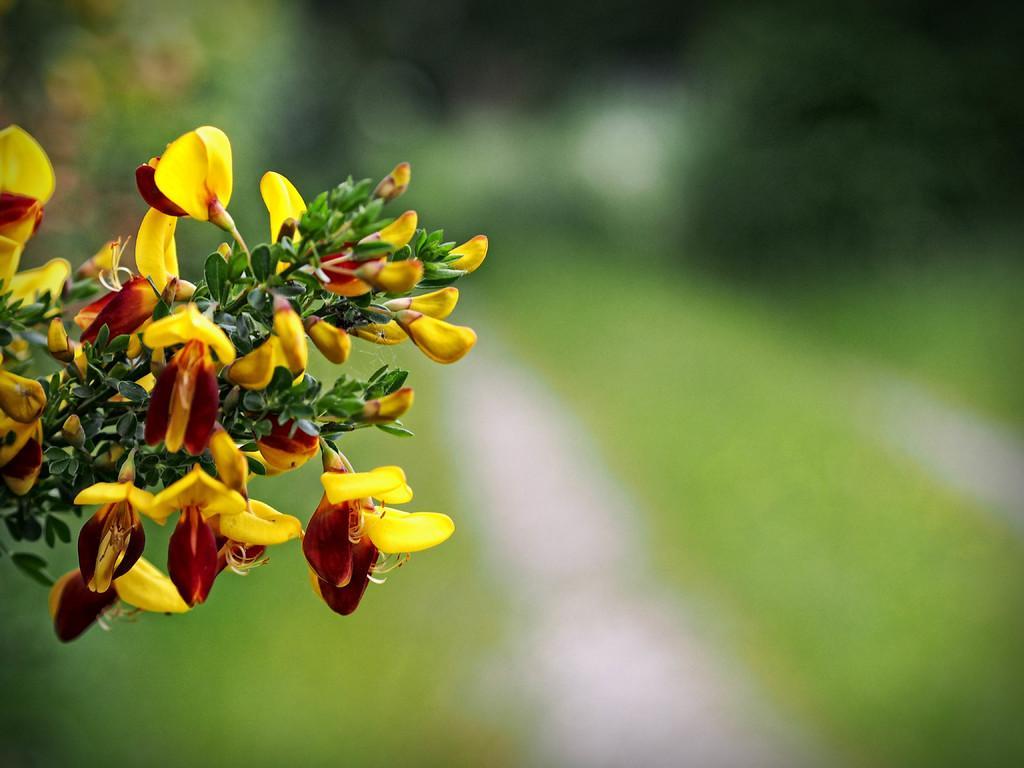In one or two sentences, can you explain what this image depicts? In this image we can see the stem of a plant with some flowers and leaves. 